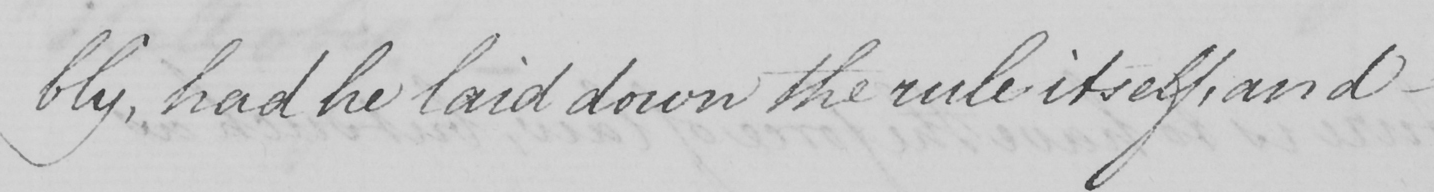Can you read and transcribe this handwriting? bly , had he laid down the rule itself , and  _ 